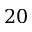<formula> <loc_0><loc_0><loc_500><loc_500>2 0</formula> 